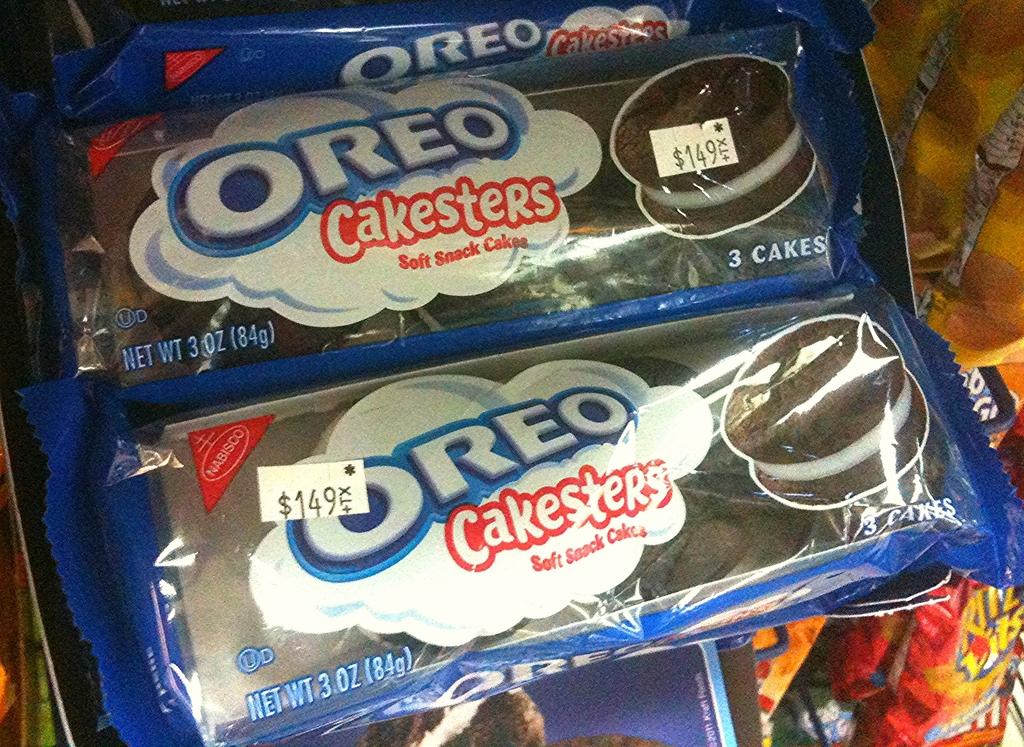What type of products are visible in the image? There are cake packets and covers in the image. Where might the cake packets and covers be located? They may be on a stand in the image. What type of establishment might the image have been taken in? The image may have been taken in a shop. What type of wrench is being used to assemble the bike in the image? There is no wrench or bike present in the image; it features cake packets and covers. What type of house is shown in the image? There is no house shown in the image; it features cake packets and covers. 